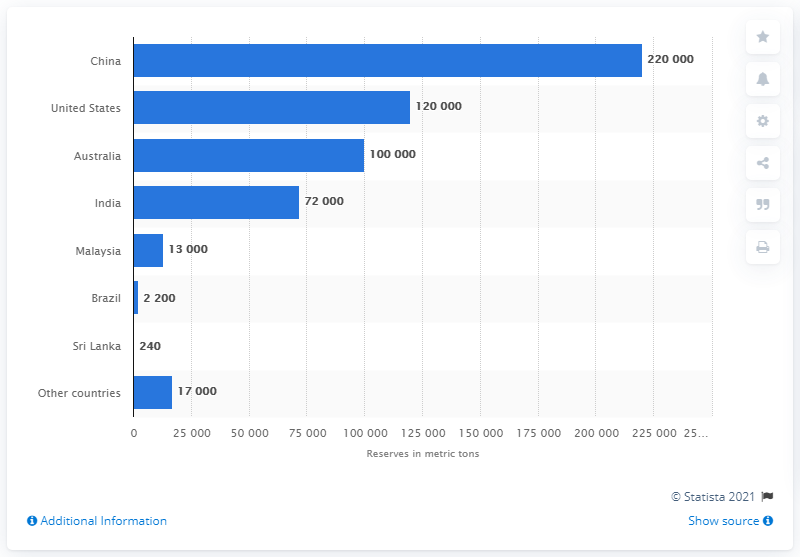Specify some key components in this picture. It is widely known that China is the country with the highest yttrium reserves. The reserves in Sri Lanka, Brazil, and Malaysia are 15,440, 22,840, and 21,650 respectively. In 2013, it was China that held the largest reserves of yttrium. 